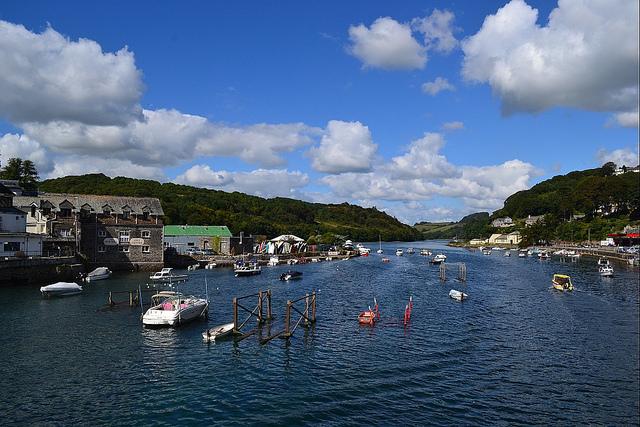How many boats are there?
Give a very brief answer. 9. Is the boat close to the island?
Answer briefly. Yes. What is overlooking the body of water?
Quick response, please. Hills. How many boats are pictured?
Keep it brief. 20. Is this a rural scene?
Be succinct. Yes. Is this the open water?
Keep it brief. No. Are there canoes in the image?
Answer briefly. No. What are the orange poles sticking out of the water?
Answer briefly. Buoys. Too many to count?
Quick response, please. Yes. 